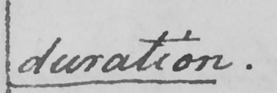What does this handwritten line say? duration . 